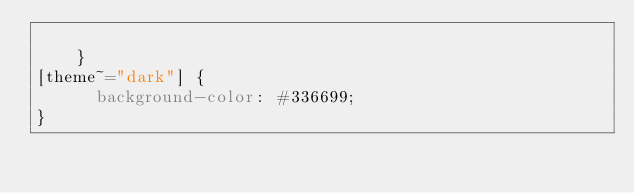Convert code to text. <code><loc_0><loc_0><loc_500><loc_500><_CSS_>
    }
[theme~="dark"] {
      background-color: #336699;
}
</code> 